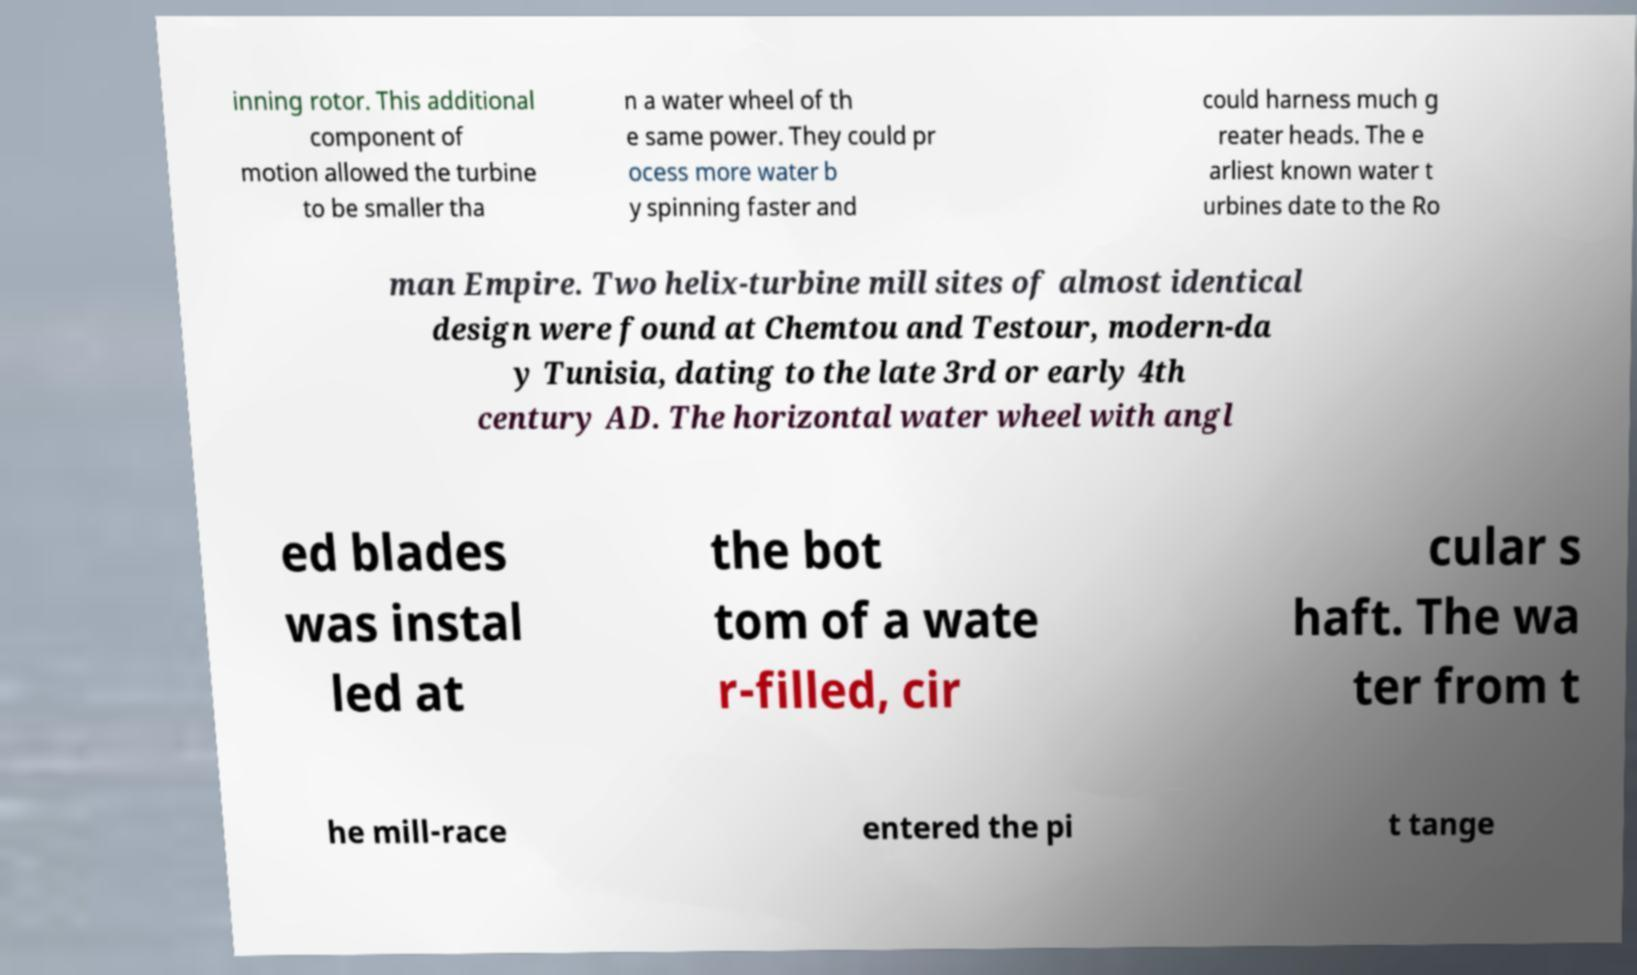For documentation purposes, I need the text within this image transcribed. Could you provide that? inning rotor. This additional component of motion allowed the turbine to be smaller tha n a water wheel of th e same power. They could pr ocess more water b y spinning faster and could harness much g reater heads. The e arliest known water t urbines date to the Ro man Empire. Two helix-turbine mill sites of almost identical design were found at Chemtou and Testour, modern-da y Tunisia, dating to the late 3rd or early 4th century AD. The horizontal water wheel with angl ed blades was instal led at the bot tom of a wate r-filled, cir cular s haft. The wa ter from t he mill-race entered the pi t tange 